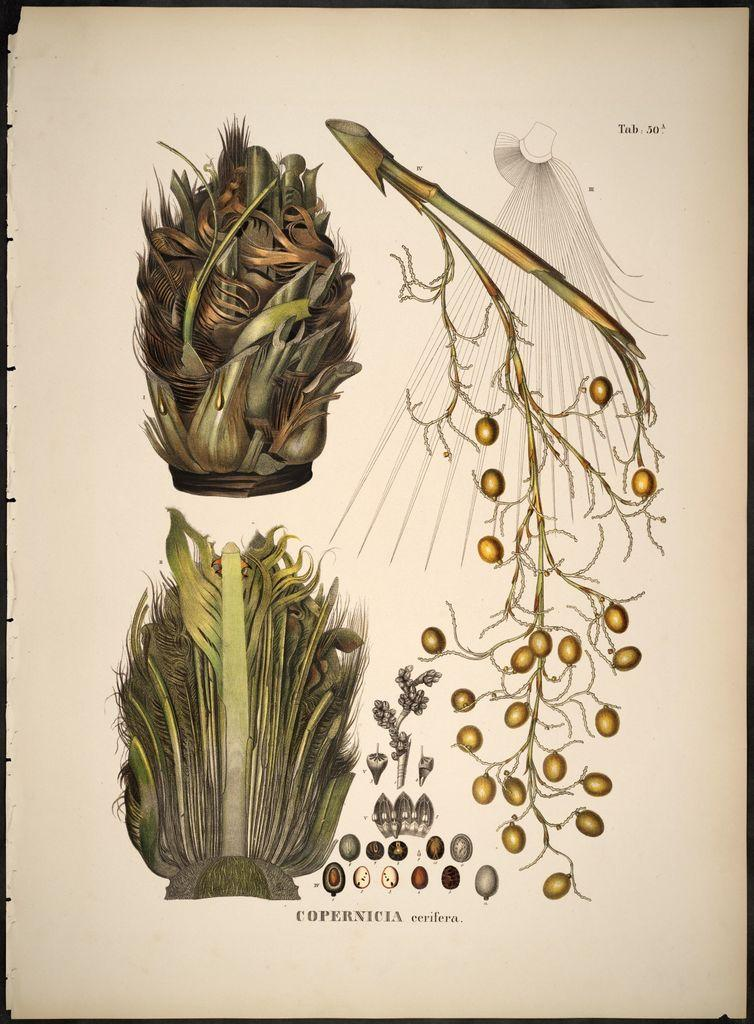What type of drawings are present in the image? The image contains drawings of leaves and branches. What is the medium for these drawings? The drawings are on a paper. Are there any words or text on the paper? Yes, there is writing on the paper. What type of stamp can be seen on the pot in the image? There is no pot or stamp present in the image; it features drawings of leaves and branches on a paper with writing. What role does the war play in the image? There is no mention or depiction of war in the image. 